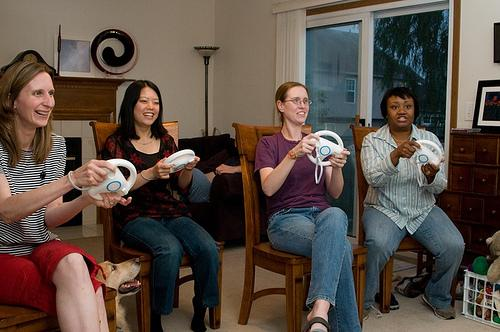What activity is the video game system simulating? driving 